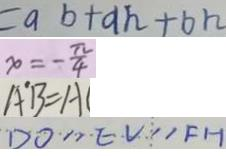Convert formula to latex. <formula><loc_0><loc_0><loc_500><loc_500>= a b + a h + b h 
 x = - \frac { \pi } { 4 } 
 A ^ { \prime } B = A 
 D O / / E V / / F H</formula> 